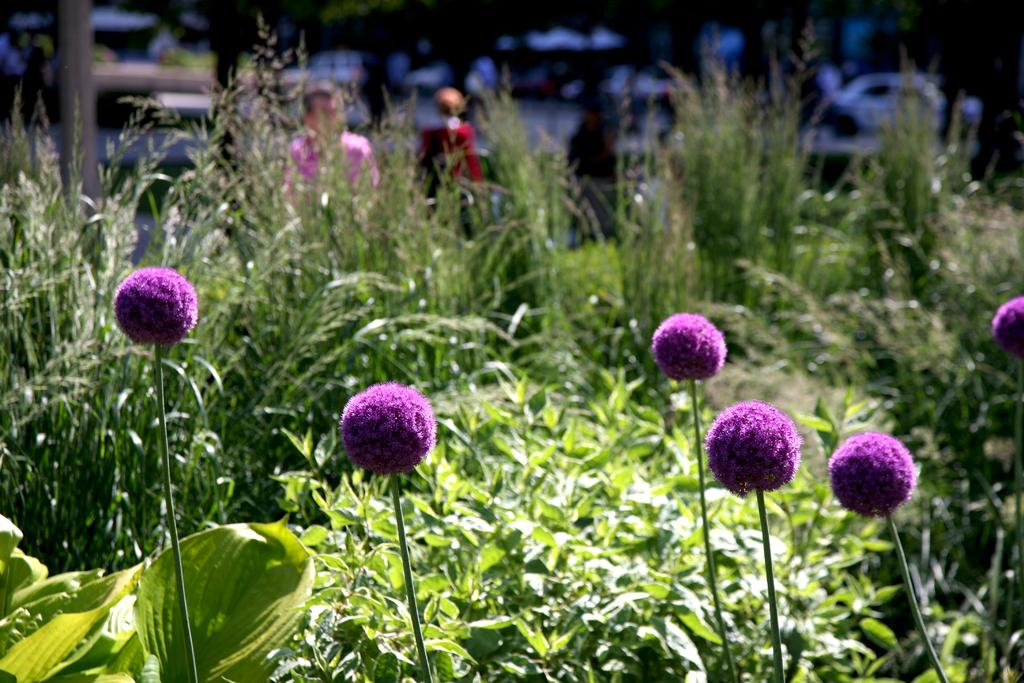What type of flora can be seen in the image? There are flowers in the image. What else can be seen in the background of the image? There is a group of plants and the bark of a tree visible in the background of the image. Are there any people present in the image? Yes, there are two people standing in the background of the image. What type of silverware is being used by the grandmother in the image? There is no grandmother or silverware present in the image. How many branches are visible in the image? The image does not specifically mention branches; it only mentions the bark of a tree. 